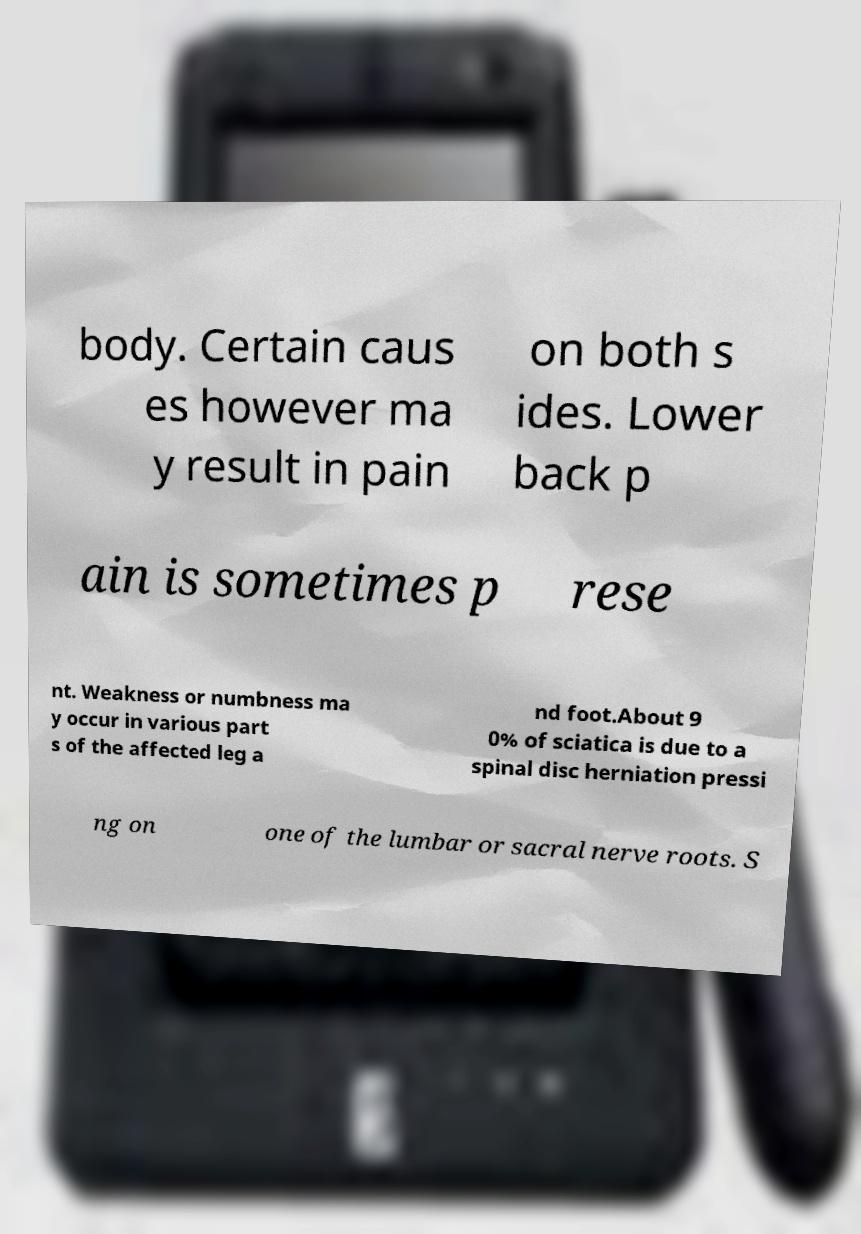Please identify and transcribe the text found in this image. body. Certain caus es however ma y result in pain on both s ides. Lower back p ain is sometimes p rese nt. Weakness or numbness ma y occur in various part s of the affected leg a nd foot.About 9 0% of sciatica is due to a spinal disc herniation pressi ng on one of the lumbar or sacral nerve roots. S 